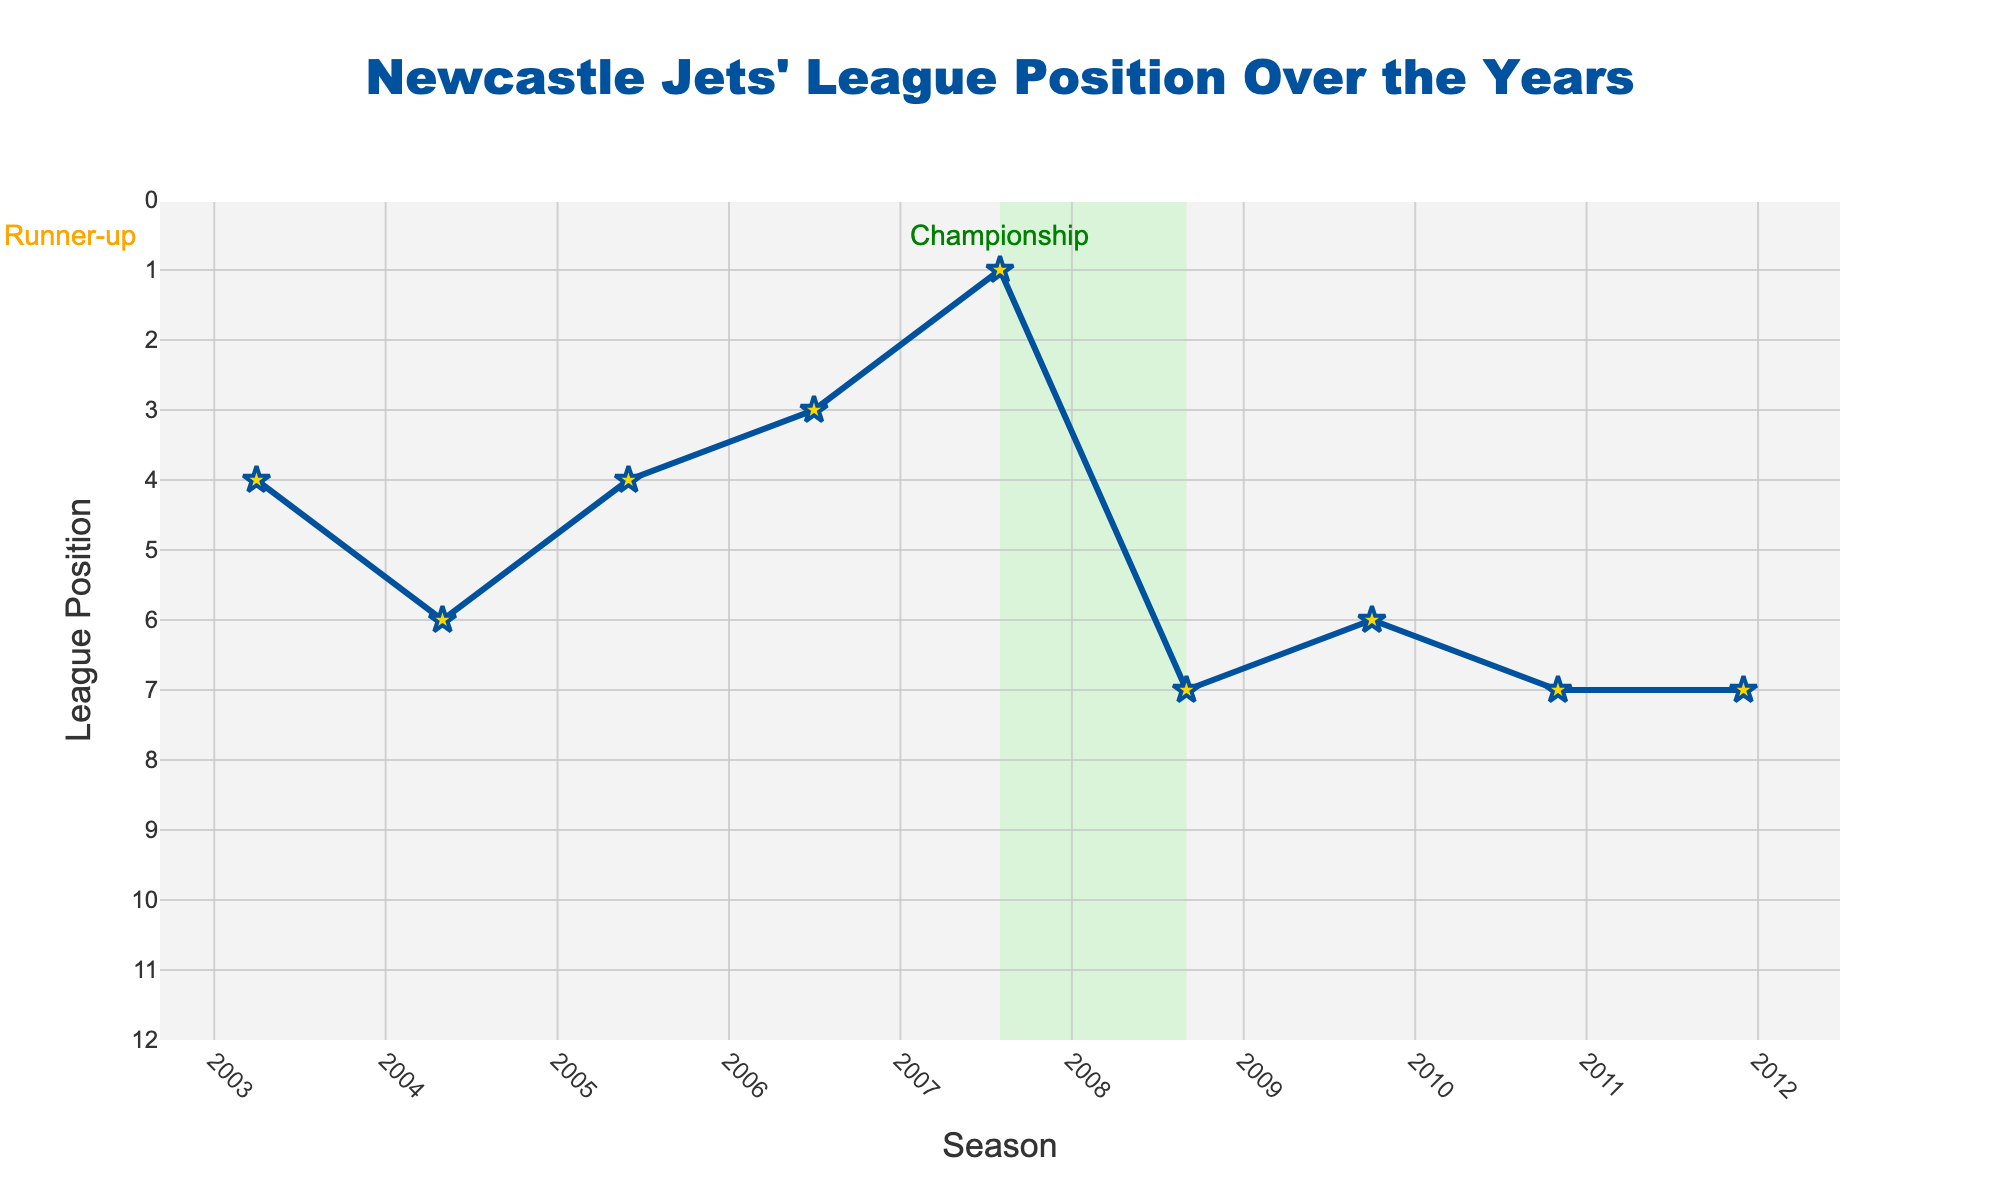How many times have Newcastle Jets finished in 7th place? The league positions show Newcastle Jets finished 7th in 2008-09, 2010-11, 2011-12, 2013-14, 2014-15, and 2018-19. Counting these occurrences gives 6 times.
Answer: 6 Which season did Newcastle Jets achieve their highest league position? The highest position shown in the chart is 1st place, which Newcastle Jets achieved in the 2007-08 season.
Answer: 2007-08 What is the difference in league position between the 2017-18 and the 2022-23 seasons? The league position in 2017-18 was 2nd, and in 2022-23 it was 11th. The difference is 11 - 2 = 9.
Answer: 9 What was the average league position of Newcastle Jets over the first five seasons? The league positions for the first five seasons (2003-04 to 2007-08) are 4, 6, 4, 3, and 1. The average is (4 + 6 + 4 + 3 + 1) / 5 = 18 / 5 = 3.6.
Answer: 3.6 During which seasons were Newcastle Jets placed in the bottom half of the league (positions 7 to 12)? The bottom half of the league includes positions 7 to 12. The seasons with positions in this range are 2008-09, 2010-11, 2011-12, 2012-13, 2013-14, 2014-15, 2015-16, 2016-17, 2018-19, 2019-20, 2020-21, 2021-22, and 2022-23.
Answer: 2008-09, 2010-11, 2011-12, 2012-13, 2013-14, 2014-15, 2015-16, 2016-17, 2018-19, 2019-20, 2020-21, 2021-22, 2022-23 Compare the number of seasons Newcastle Jets positioned in the top 4 to those in the bottom 4 (positions 9 to 12). Which is greater? The top 4 positions were achieved in four seasons: 2003-04, 2005-06, 2006-07, and 2017-18. The bottom 4 positions were achieved in five seasons: 2012-13, 2015-16, 2016-17, 2020-21, and 2022-23. Bottom 4 has one more season compared to top 4.
Answer: Bottom 4 